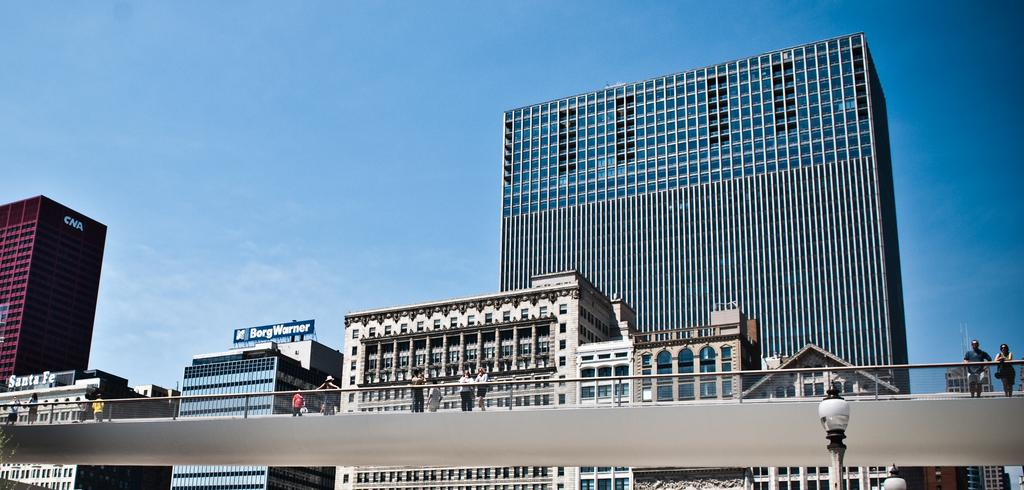What type of structures can be seen in the image? There are many buildings in the image. What kind of transportation infrastructure is present in the image? There is a bridge with railing in the image. Are there any people visible in the image? Yes, some people are standing on the bridge. What can be seen in the distance in the image? There is a sky visible in the background of the image. What type of cloth is being used to mine in the image? There is no cloth or mining activity present in the image. What show is being performed on the bridge in the image? There is no show or performance taking place on the bridge in the image. 